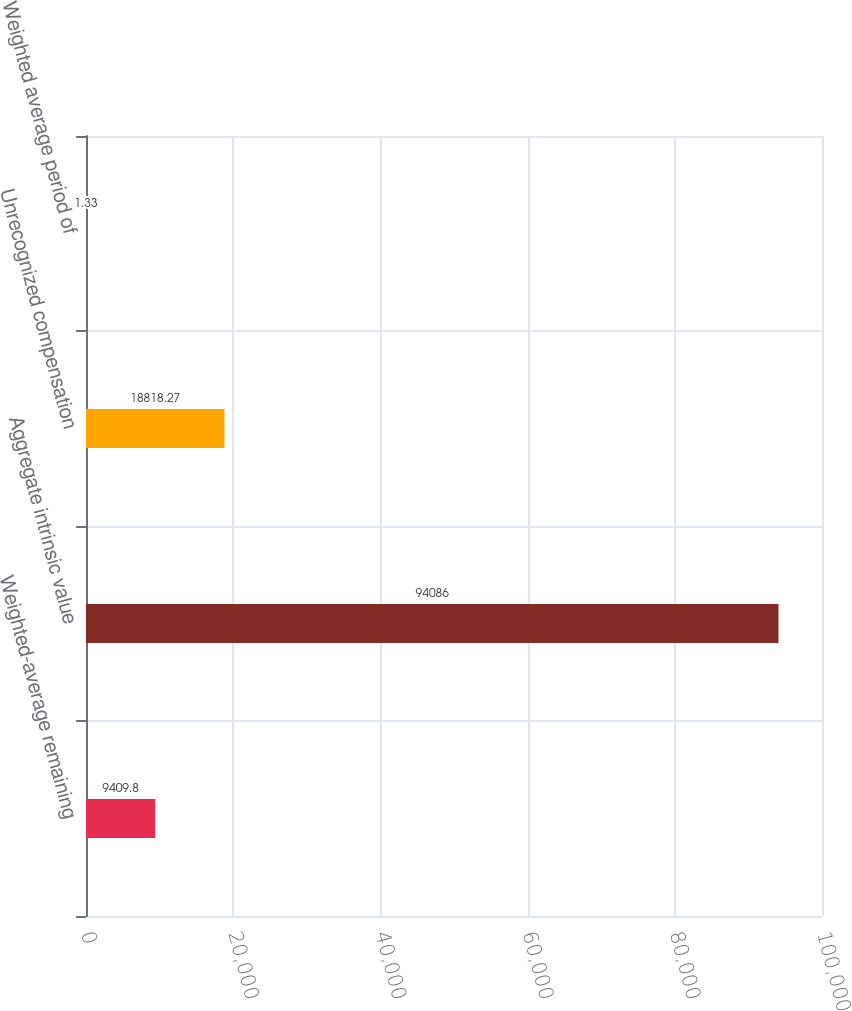Convert chart to OTSL. <chart><loc_0><loc_0><loc_500><loc_500><bar_chart><fcel>Weighted-average remaining<fcel>Aggregate intrinsic value<fcel>Unrecognized compensation<fcel>Weighted average period of<nl><fcel>9409.8<fcel>94086<fcel>18818.3<fcel>1.33<nl></chart> 